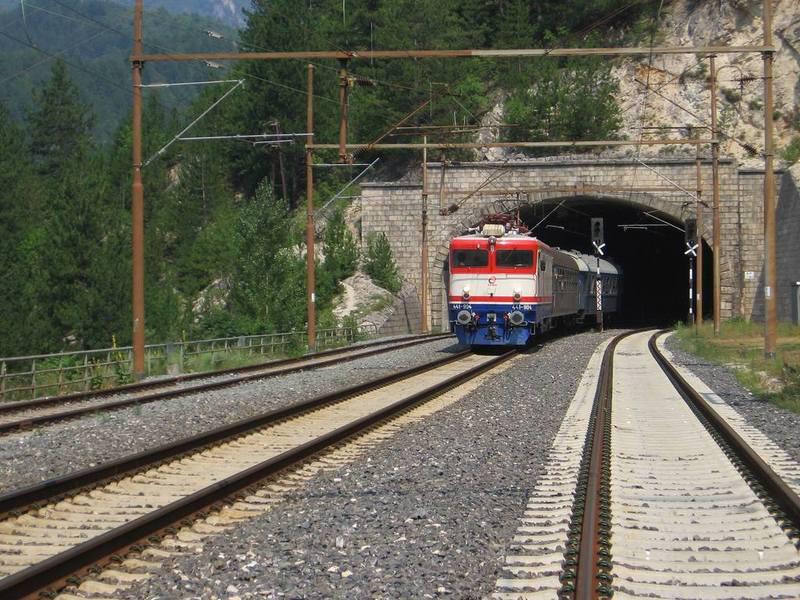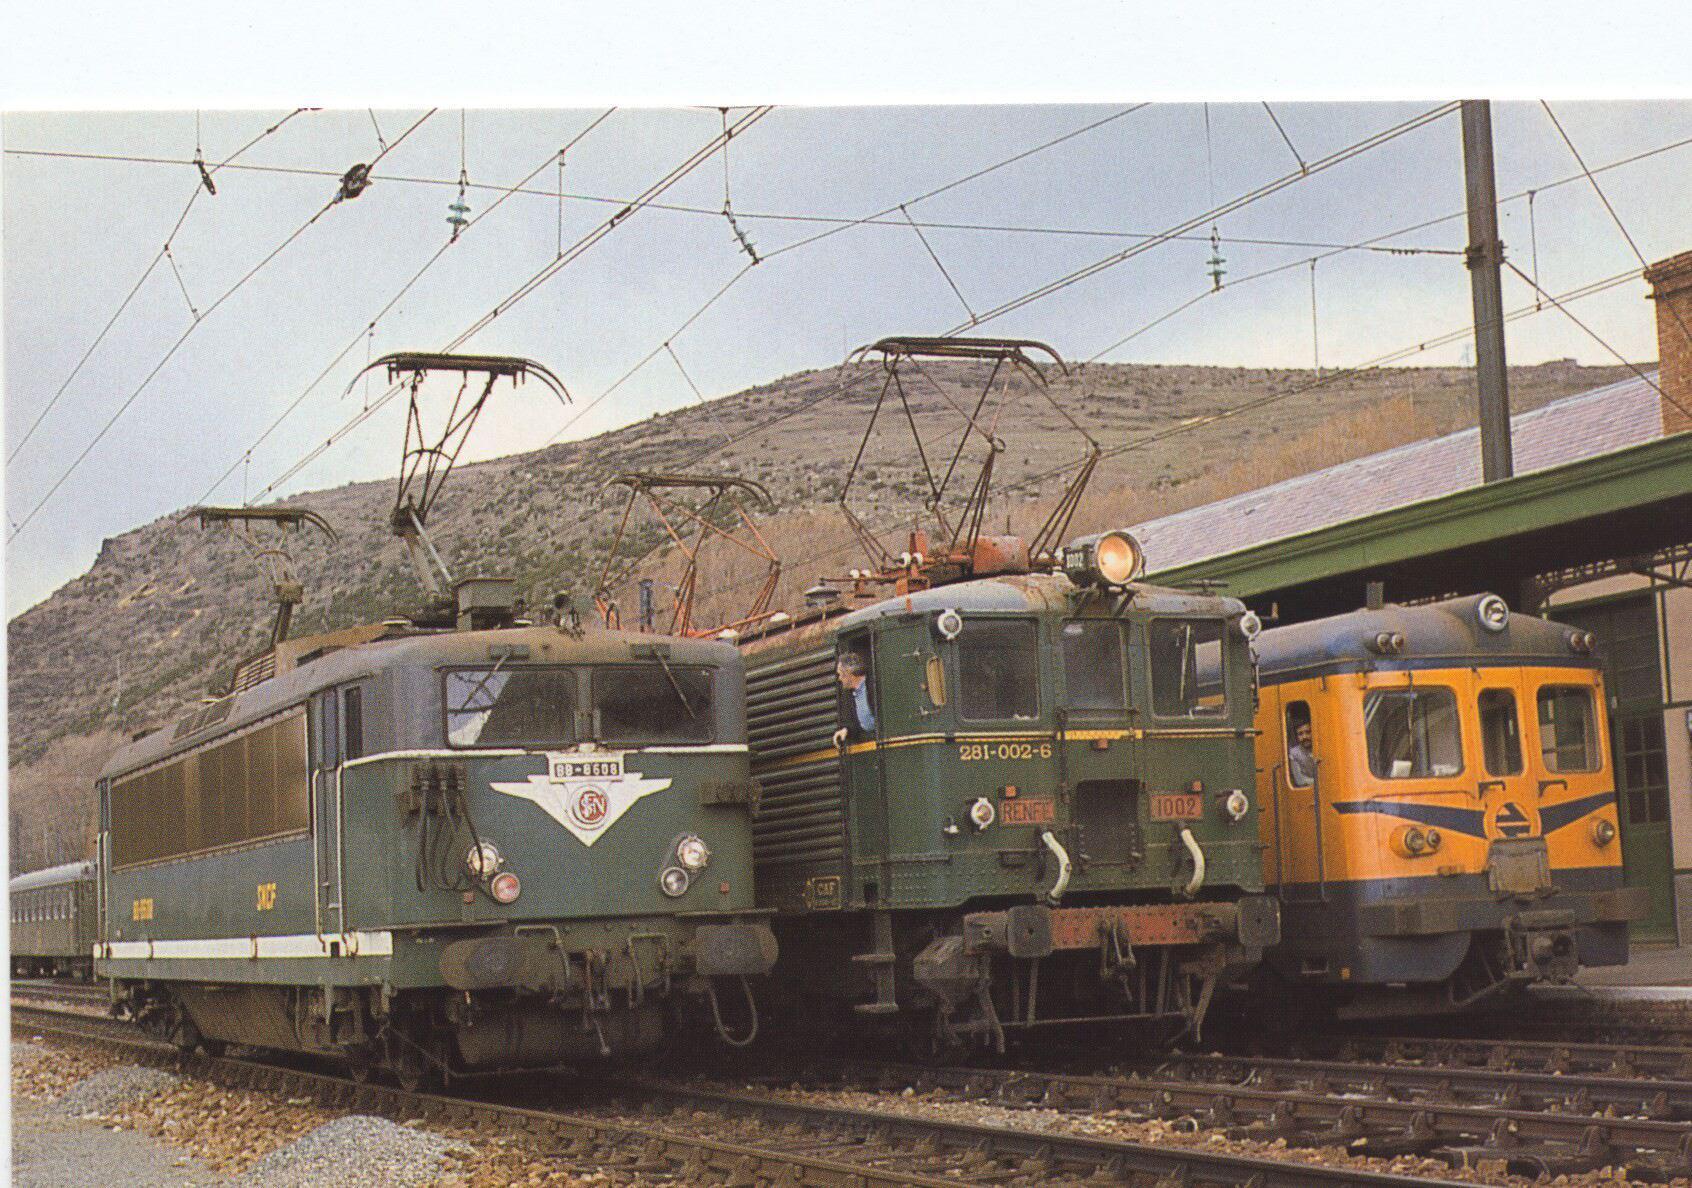The first image is the image on the left, the second image is the image on the right. Assess this claim about the two images: "One train contains the three colors red, white, and blue on the main body.". Correct or not? Answer yes or no. Yes. The first image is the image on the left, the second image is the image on the right. Given the left and right images, does the statement "Both images have trains facing towards the right." hold true? Answer yes or no. No. 